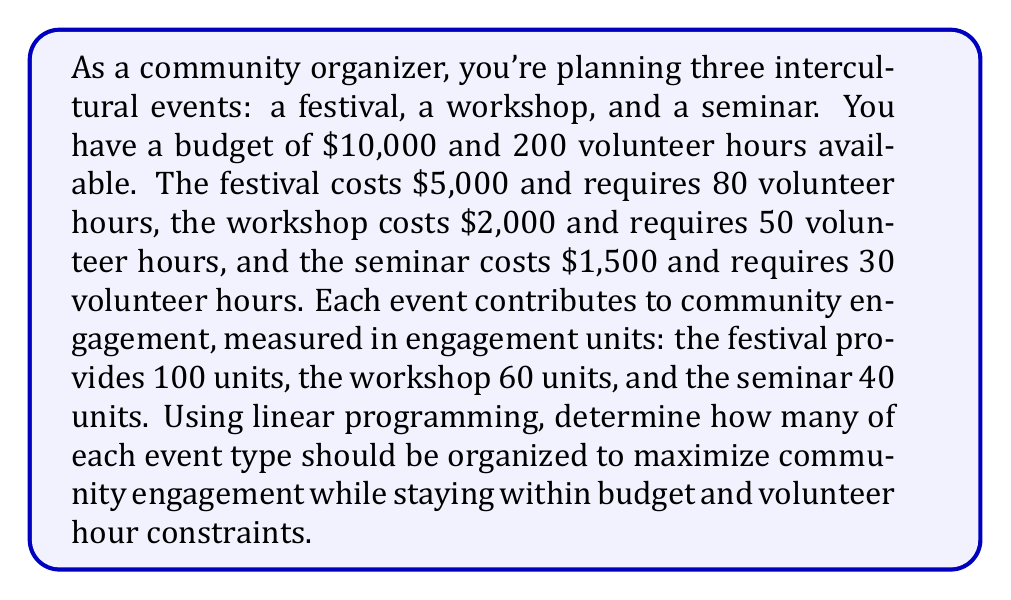Can you solve this math problem? Let's approach this step-by-step using linear programming:

1. Define variables:
   Let $x$ = number of festivals
   Let $y$ = number of workshops
   Let $z$ = number of seminars

2. Objective function:
   Maximize $100x + 60y + 40z$ (total engagement units)

3. Constraints:
   Budget: $5000x + 2000y + 1500z \leq 10000$
   Volunteer hours: $80x + 50y + 30z \leq 200$
   Non-negativity: $x, y, z \geq 0$

4. Simplify constraints:
   $5x + 2y + 1.5z \leq 10$
   $4x + 2.5y + 1.5z \leq 10$

5. Plot the constraints:
   [asy]
   import graph;
   size(200);
   xaxis("x", 0, 3);
   yaxis("y", 0, 5);
   draw((0,5)--(2,0), blue);
   draw((0,4)--(2.5,0), red);
   label("Budget", (1.5,2), E, blue);
   label("Volunteer hours", (2,2), W, red);
   [/asy]

6. Identify corner points:
   (0,0), (0,4), (2,0), and the intersection of the two lines

7. Solve for intersection:
   $5x + 2y = 10$
   $4x + 2.5y = 10$
   Subtracting equations: $x - 0.5y = 0$
   $x = 0.5y$
   Substituting into first equation:
   $5(0.5y) + 2y = 10$
   $2.5y + 2y = 10$
   $4.5y = 10$
   $y = 2.22$
   $x = 1.11$

8. Evaluate objective function at corner points:
   (0,0,0): 0
   (0,4,0): 240
   (2,0,0): 200
   (1.11, 2.22, 0): 244.4

9. The maximum engagement is achieved at (1.11, 2.22, 0), but we need integer solutions.

10. Check nearby integer solutions:
    (1,2,0): 220
    (1,2,1): 260

Therefore, the optimal integer solution is to organize 1 festival, 2 workshops, and 1 seminar.
Answer: 1 festival, 2 workshops, 1 seminar 